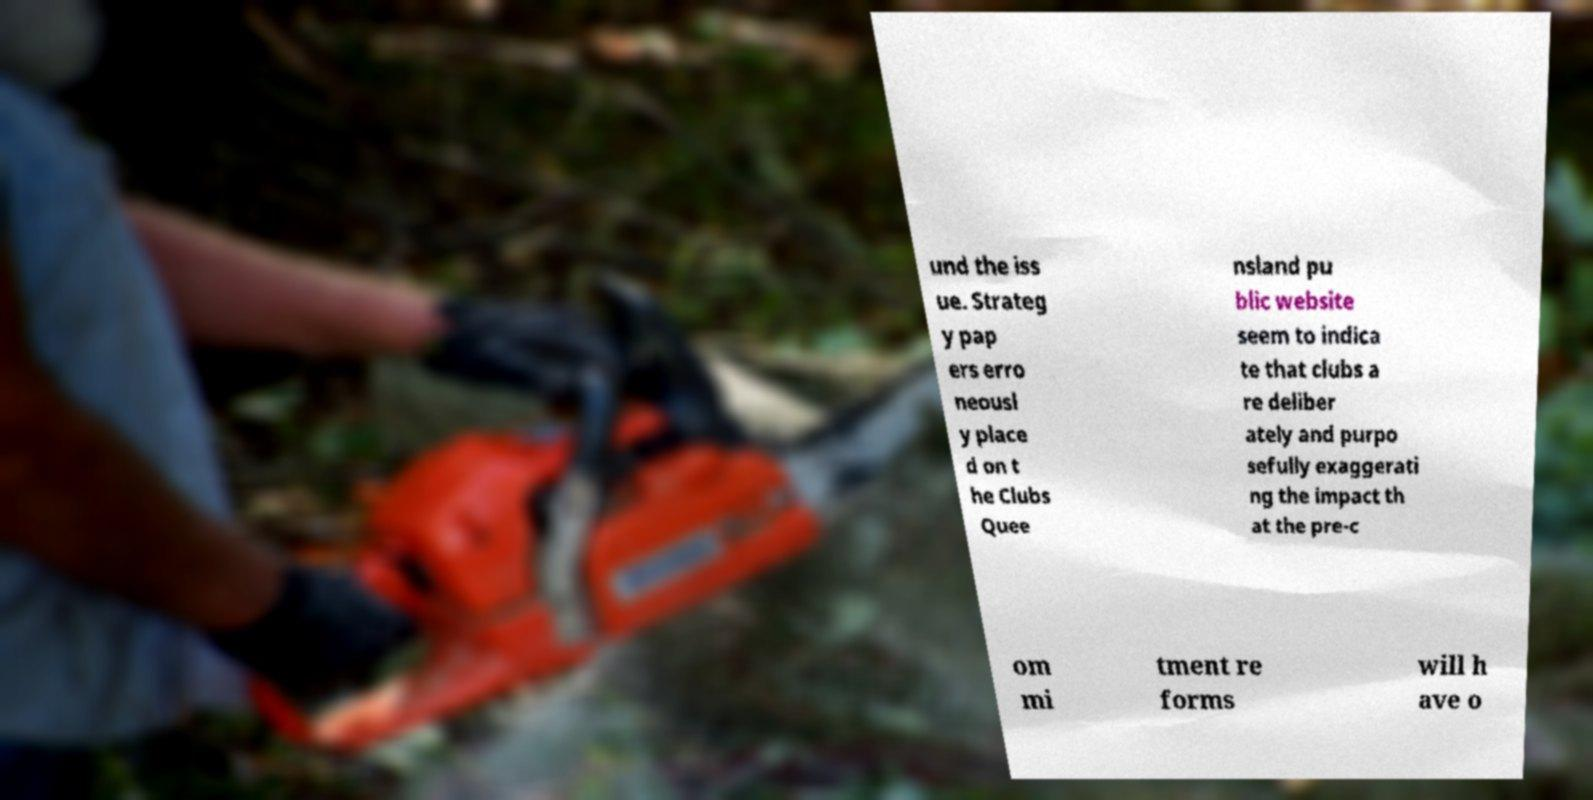Could you assist in decoding the text presented in this image and type it out clearly? und the iss ue. Strateg y pap ers erro neousl y place d on t he Clubs Quee nsland pu blic website seem to indica te that clubs a re deliber ately and purpo sefully exaggerati ng the impact th at the pre-c om mi tment re forms will h ave o 